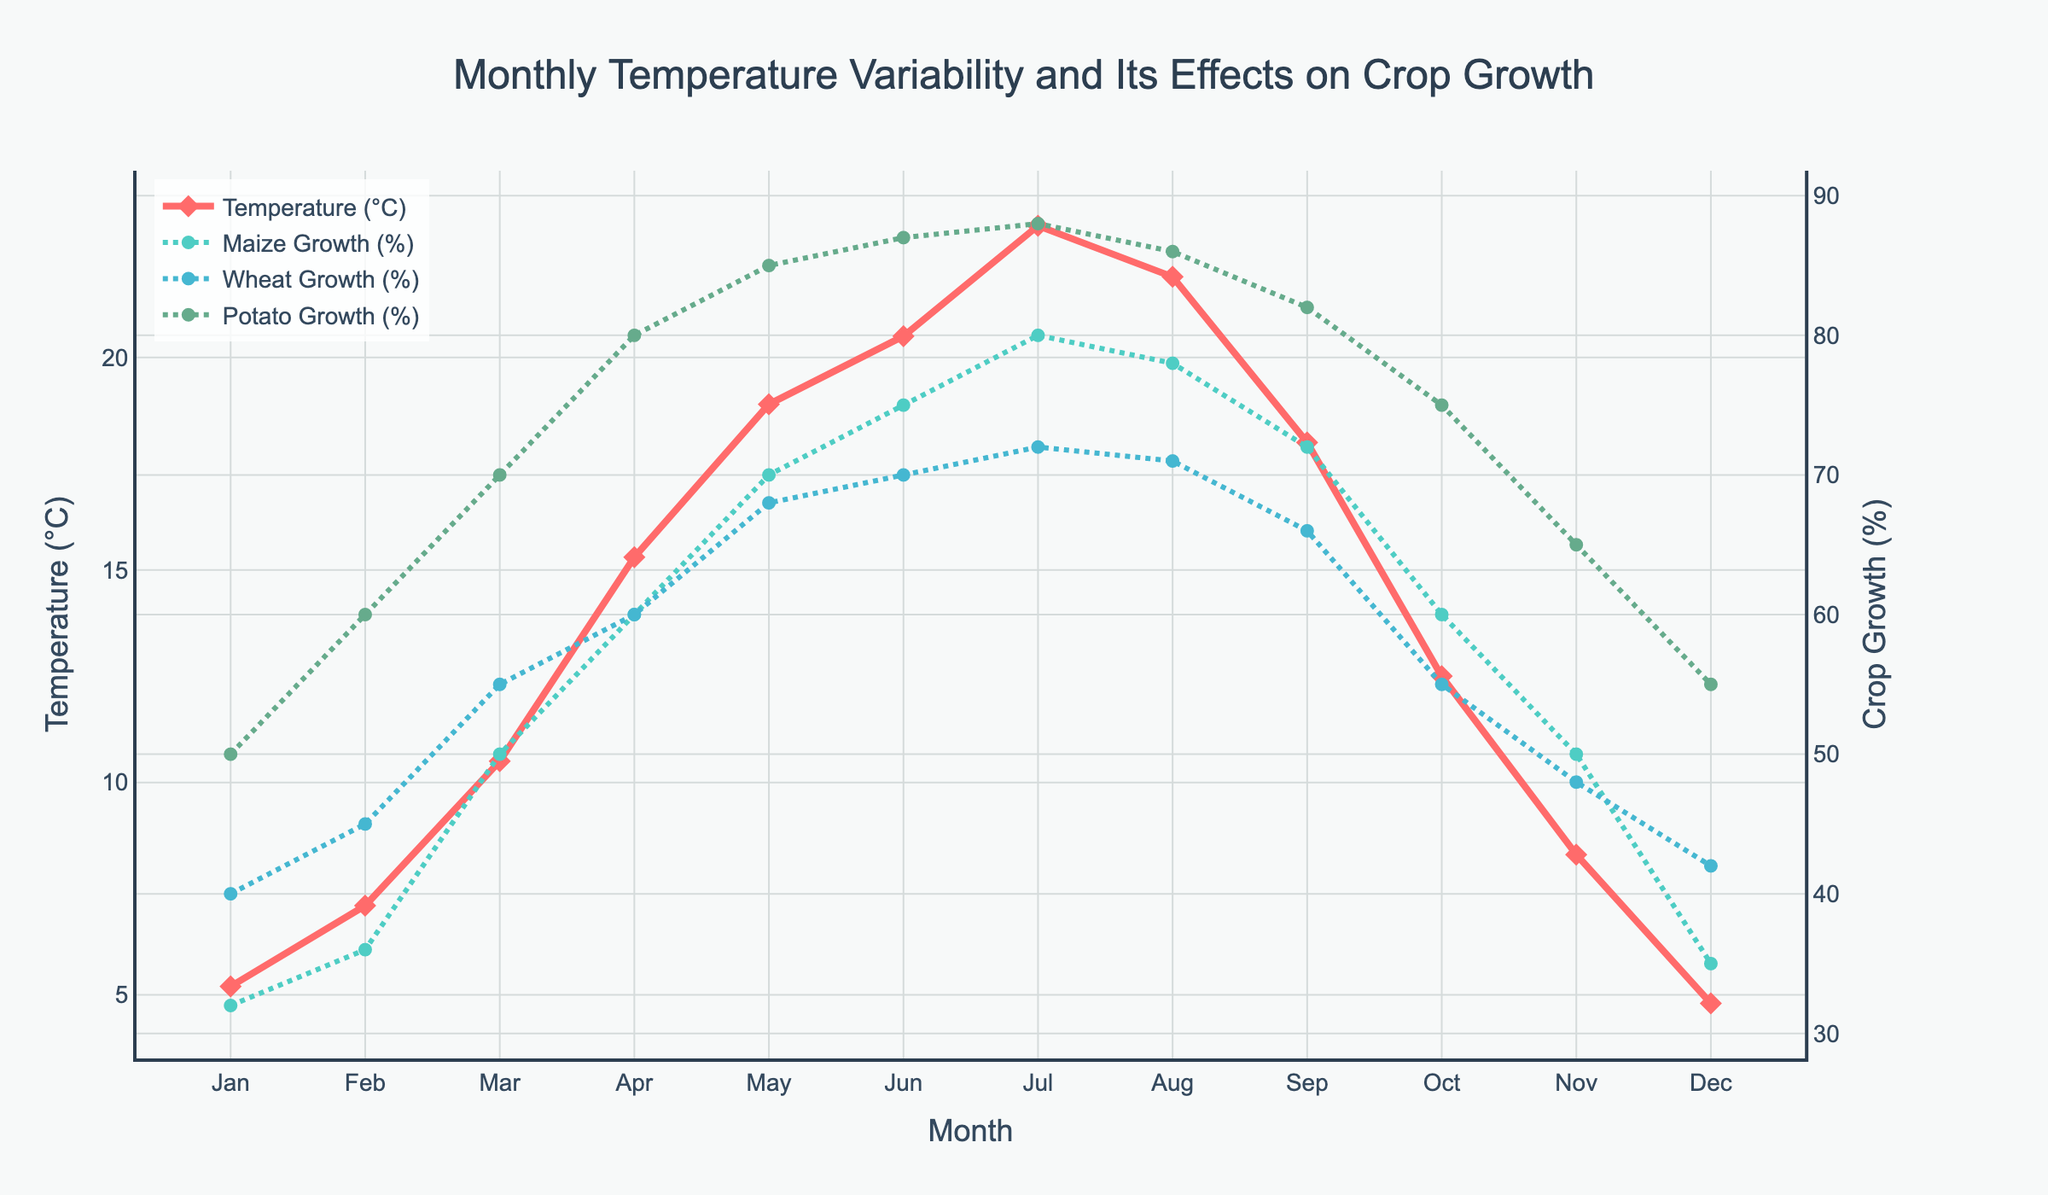What's the title of the figure? The title of the figure is prominently displayed at the top and is visually highlighted.
Answer: Monthly Temperature Variability and Its Effects on Crop Growth Which month has the highest temperature recorded? The line representing temperature (in red) reaches its peak in July on the x-axis.
Answer: July At what temperature does Potato growth reach its maximum percentage? Observing the green line for Potato Growth and the red line for Temperature, Potato growth is highest in July when the temperature is 23.1°C.
Answer: 23.1°C Is there a month where the Maize growth percentage equals the Wheat growth percentage? Both lines for Maize and Wheat growth percentages intersect in April, where both growth percentages are 60%.
Answer: April What's the average temperature from Jan to Dec? Adding all monthly temperatures (5.2+7.1+10.5+15.3+18.9+20.5+23.1+21.9+18.0+12.5+8.3+4.8) and dividing by 12 gives the average.
Answer: 13.6°C Which crop shows the largest growth difference between the months of August and September? For each crop, subtract August's percentage from September's: Maize (78-72 = 6), Wheat (71-66 = 5), and Potato (86-82 = 4). The largest difference is in Maize.
Answer: Maize In which months does Wheat growth percentage fall below 50%? The yellow line for Wheat growth shows percentages below 50 in January, February, November, and December.
Answer: January, February, November, December Compare Potato growth percentages in March and November. In November, Potato growth is at 65%, and in March, it's 70%.
Answer: March has a higher percentage than November Is there a general trend in Maize growth as temperatures rise? As observed, the Maize growth percentage generally increases as the temperature goes up from January to July, showing a positive correlation.
Answer: The growth percentage increases How much does the growth percentage of Wheat change from its lowest to highest month? The lowest Wheat growth is in December (42%), and the highest is in July (72%). The difference is 72-42.
Answer: 30_percentage points 